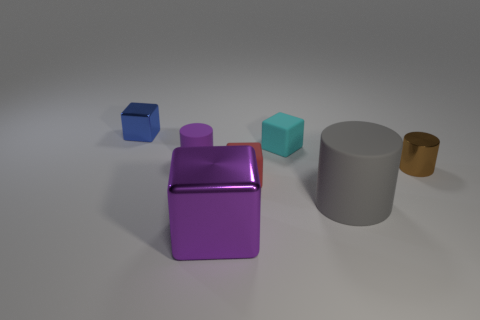There is a object that is behind the brown metallic cylinder and right of the red cube; how big is it?
Ensure brevity in your answer.  Small. There is a brown metallic cylinder; how many tiny cubes are behind it?
Your response must be concise. 2. What shape is the shiny thing that is both on the left side of the big gray cylinder and behind the gray thing?
Your response must be concise. Cube. What material is the object that is the same color as the large shiny block?
Make the answer very short. Rubber. What number of cubes are either small purple matte things or small brown things?
Make the answer very short. 0. What is the size of the other object that is the same color as the big metallic thing?
Provide a short and direct response. Small. Is the number of brown shiny cylinders left of the gray object less than the number of small brown metal balls?
Offer a very short reply. No. What is the color of the cylinder that is right of the big metallic thing and behind the big matte thing?
Make the answer very short. Brown. How many other objects are there of the same shape as the small red rubber thing?
Your answer should be very brief. 3. Is the number of cylinders that are to the left of the small metal cube less than the number of red objects that are on the right side of the big purple cube?
Keep it short and to the point. Yes. 